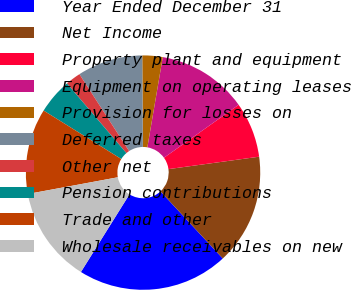Convert chart. <chart><loc_0><loc_0><loc_500><loc_500><pie_chart><fcel>Year Ended December 31<fcel>Net Income<fcel>Property plant and equipment<fcel>Equipment on operating leases<fcel>Provision for losses on<fcel>Deferred taxes<fcel>Other net<fcel>Pension contributions<fcel>Trade and other<fcel>Wholesale receivables on new<nl><fcel>20.8%<fcel>15.26%<fcel>7.65%<fcel>12.49%<fcel>2.8%<fcel>9.03%<fcel>2.11%<fcel>4.88%<fcel>11.8%<fcel>13.19%<nl></chart> 